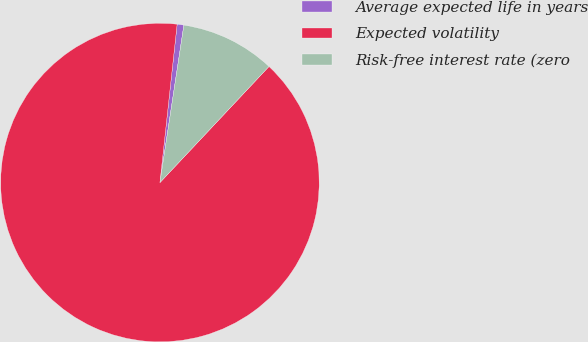Convert chart. <chart><loc_0><loc_0><loc_500><loc_500><pie_chart><fcel>Average expected life in years<fcel>Expected volatility<fcel>Risk-free interest rate (zero<nl><fcel>0.68%<fcel>89.72%<fcel>9.6%<nl></chart> 